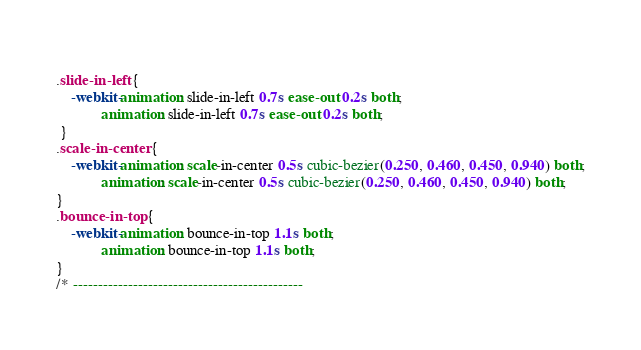Convert code to text. <code><loc_0><loc_0><loc_500><loc_500><_CSS_> 
.slide-in-left {
	-webkit-animation: slide-in-left 0.7s ease-out 0.2s both;
            animation: slide-in-left 0.7s ease-out 0.2s both;
 }
.scale-in-center {
	-webkit-animation: scale-in-center 0.5s cubic-bezier(0.250, 0.460, 0.450, 0.940) both;
	        animation: scale-in-center 0.5s cubic-bezier(0.250, 0.460, 0.450, 0.940) both;
}
.bounce-in-top {
	-webkit-animation: bounce-in-top 1.1s both;
	        animation: bounce-in-top 1.1s both;
}
/* ----------------------------------------------</code> 